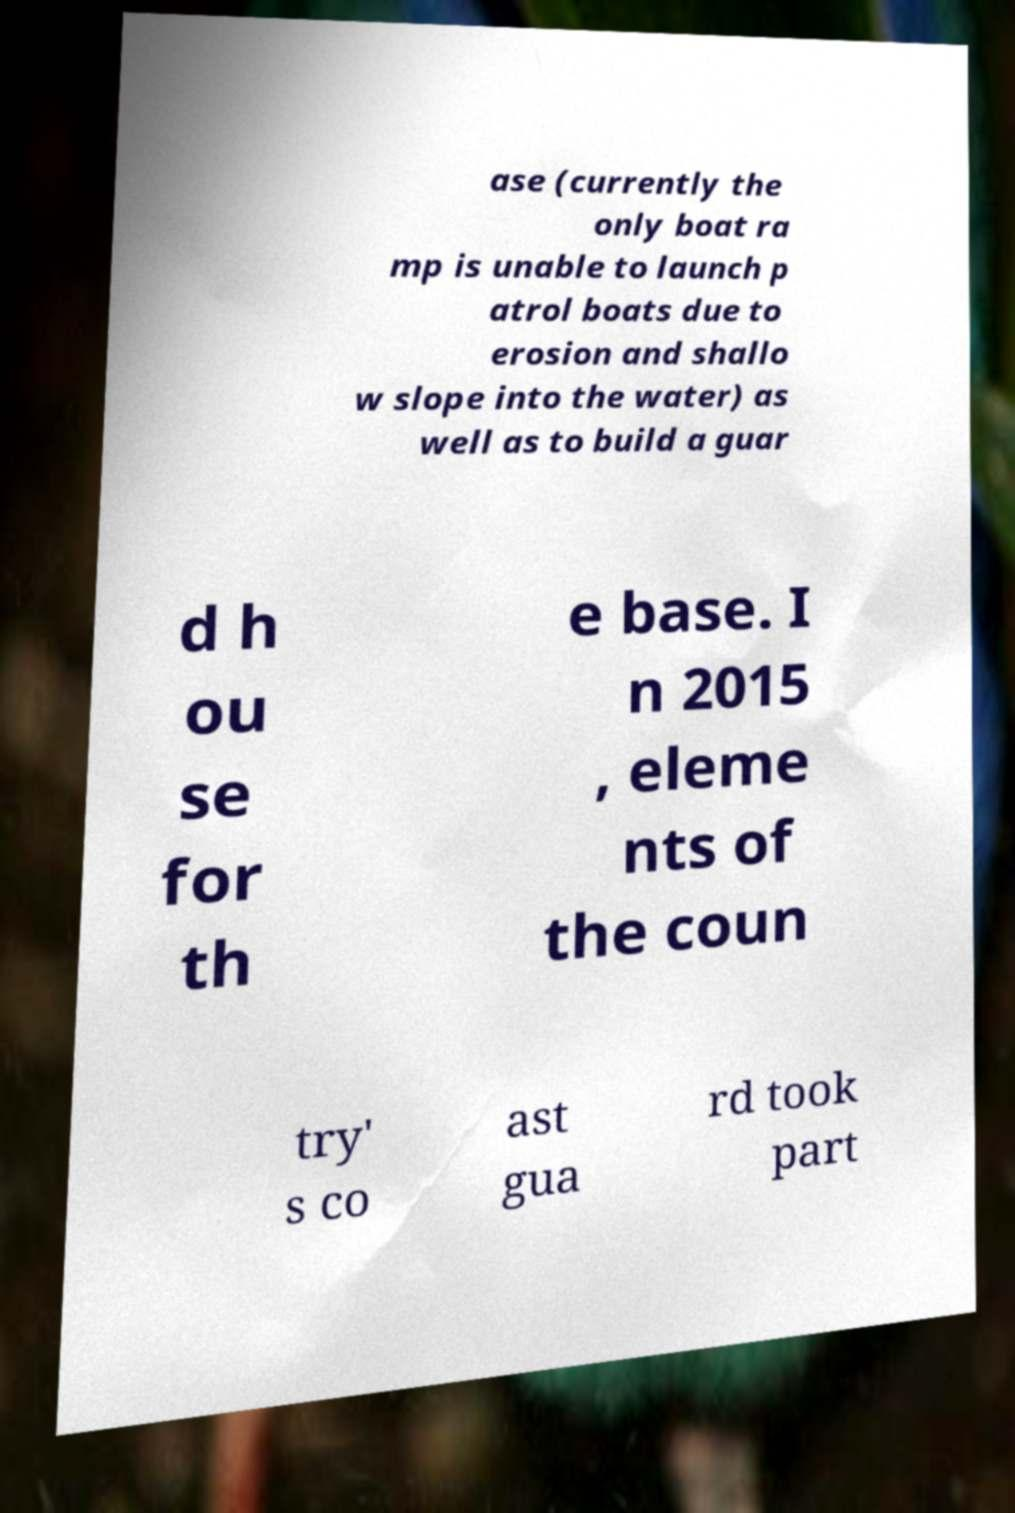Please read and relay the text visible in this image. What does it say? ase (currently the only boat ra mp is unable to launch p atrol boats due to erosion and shallo w slope into the water) as well as to build a guar d h ou se for th e base. I n 2015 , eleme nts of the coun try' s co ast gua rd took part 